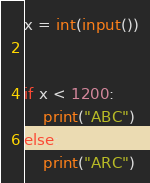<code> <loc_0><loc_0><loc_500><loc_500><_Python_>x = int(input())


if x < 1200:
    print("ABC")
else:
    print("ARC")</code> 